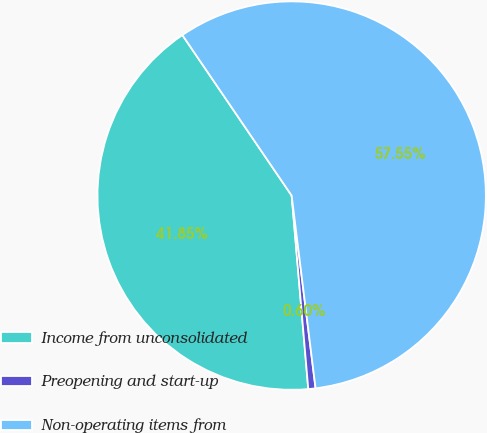Convert chart. <chart><loc_0><loc_0><loc_500><loc_500><pie_chart><fcel>Income from unconsolidated<fcel>Preopening and start-up<fcel>Non-operating items from<nl><fcel>41.85%<fcel>0.6%<fcel>57.55%<nl></chart> 